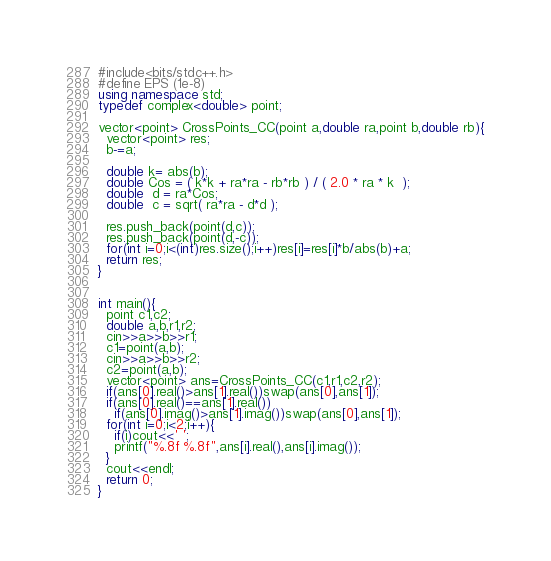Convert code to text. <code><loc_0><loc_0><loc_500><loc_500><_C++_>#include<bits/stdc++.h>
#define EPS (1e-8)
using namespace std;
typedef complex<double> point;

vector<point> CrossPoints_CC(point a,double ra,point b,double rb){
  vector<point> res;
  b-=a;

  double k= abs(b);
  double Cos = ( k*k + ra*ra - rb*rb ) / ( 2.0 * ra * k  );
  double  d = ra*Cos;
  double  c = sqrt( ra*ra - d*d );

  res.push_back(point(d,c));
  res.push_back(point(d,-c));  
  for(int i=0;i<(int)res.size();i++)res[i]=res[i]*b/abs(b)+a;
  return res;
}


int main(){
  point c1,c2;
  double a,b,r1,r2;
  cin>>a>>b>>r1;
  c1=point(a,b);
  cin>>a>>b>>r2;
  c2=point(a,b);
  vector<point> ans=CrossPoints_CC(c1,r1,c2,r2);
  if(ans[0].real()>ans[1].real())swap(ans[0],ans[1]);
  if(ans[0].real()==ans[1].real())
    if(ans[0].imag()>ans[1].imag())swap(ans[0],ans[1]);
  for(int i=0;i<2;i++){
    if(i)cout<<' ';
    printf("%.8f %.8f",ans[i].real(),ans[i].imag());
  }
  cout<<endl;
  return 0;
}</code> 